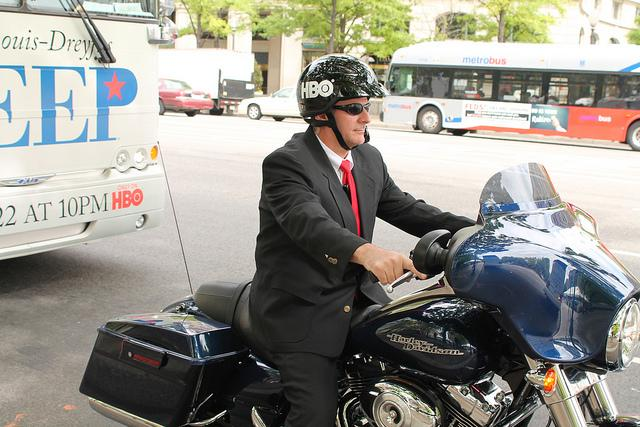The man on the motorcycle is pretending to act as what type of person?

Choices:
A) policeman
B) businessman
C) secret serviceman
D) fireman secret serviceman 